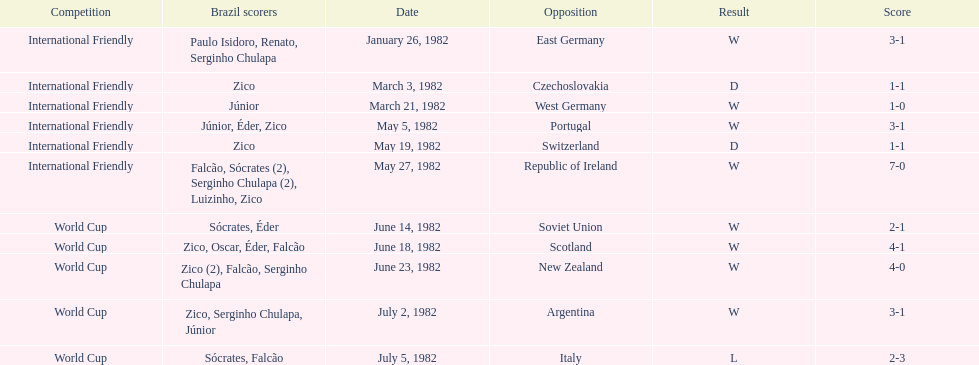How many games did zico end up scoring in during this season? 7. 